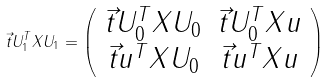Convert formula to latex. <formula><loc_0><loc_0><loc_500><loc_500>\vec { t } { U _ { 1 } ^ { T } X U _ { 1 } } = \left ( \begin{array} { c c } \vec { t } { U _ { 0 } ^ { T } X U _ { 0 } } & \vec { t } { U _ { 0 } ^ { T } X u } \\ \vec { t } { u ^ { T } X U _ { 0 } } & \vec { t } { u ^ { T } X u } \end{array} \right )</formula> 